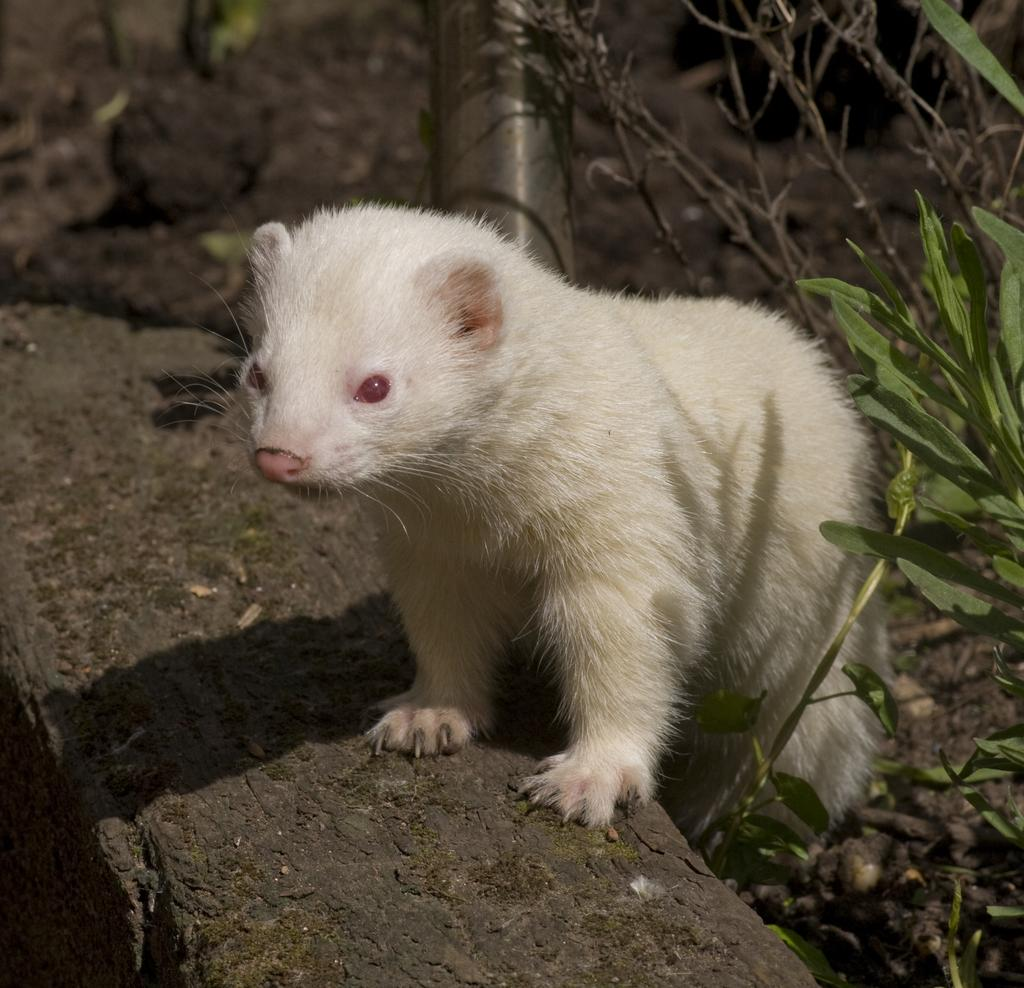What type of animal is in the image? There is a ferret in the image. What object is present in the image that the ferret might interact with? There is a pole in the image. What type of vegetation can be seen in the image? There are plants in the image. What type of ground surface is visible in the image? There are sand particles on the ground in the image. What type of jeans is the ferret wearing in the image? The ferret is not wearing jeans in the image, as ferrets do not wear clothing. 